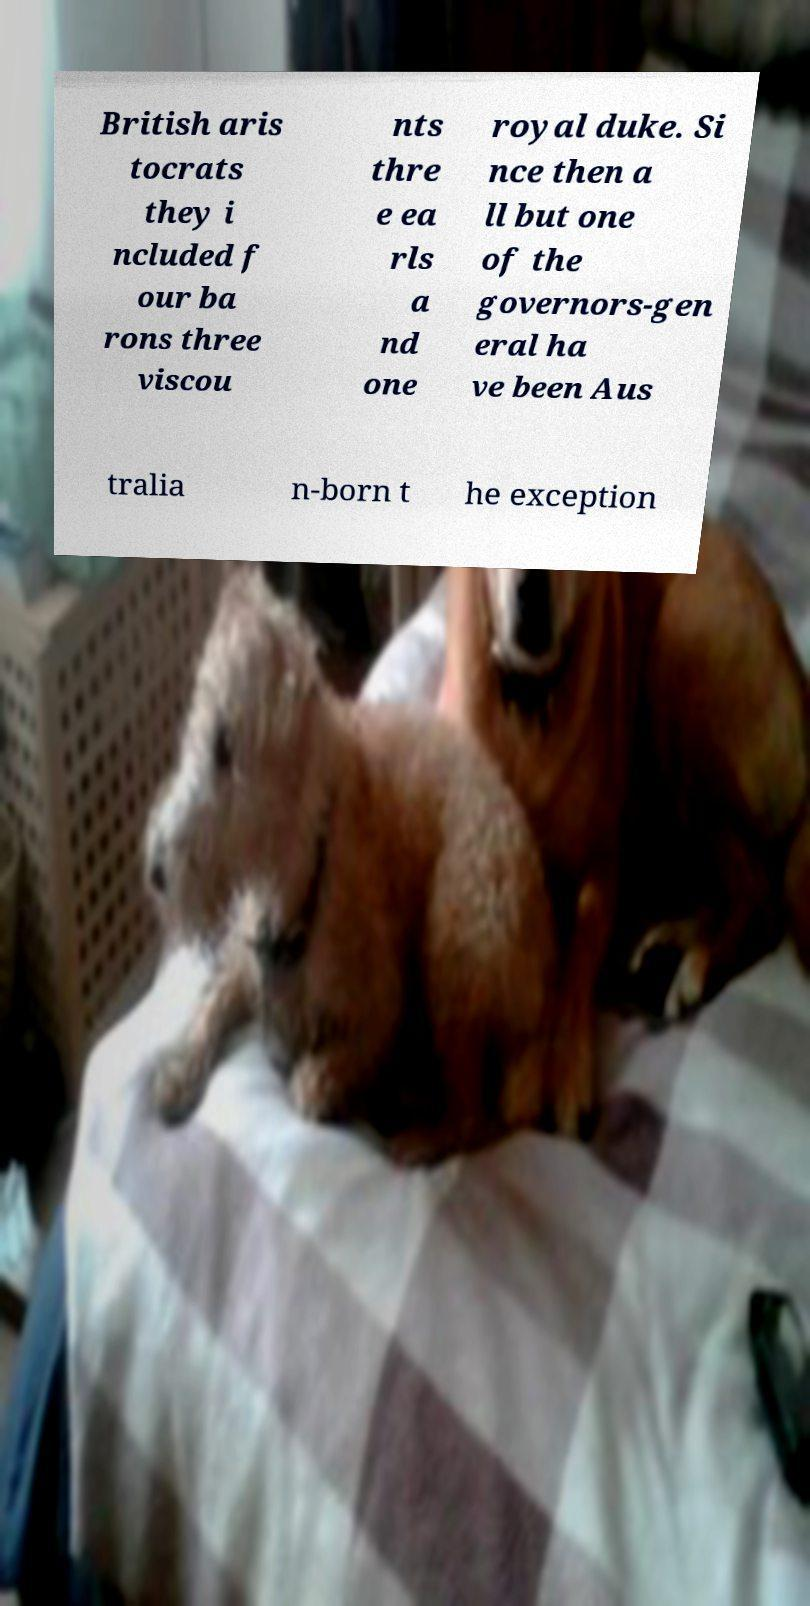Please identify and transcribe the text found in this image. British aris tocrats they i ncluded f our ba rons three viscou nts thre e ea rls a nd one royal duke. Si nce then a ll but one of the governors-gen eral ha ve been Aus tralia n-born t he exception 